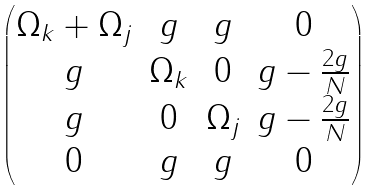Convert formula to latex. <formula><loc_0><loc_0><loc_500><loc_500>\begin{pmatrix} \Omega _ { k } + \Omega _ { j } & g & g & 0 \\ g & \Omega _ { k } & 0 & g - \frac { 2 g } { N } \\ g & 0 & \Omega _ { j } & g - \frac { 2 g } { N } \\ 0 & g & g & 0 \\ \end{pmatrix}</formula> 